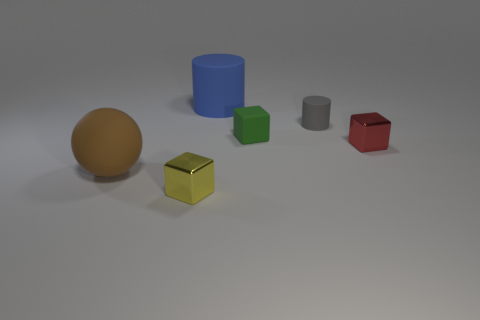Does the large rubber cylinder have the same color as the tiny rubber cylinder?
Make the answer very short. No. There is a object in front of the large object that is in front of the gray matte cylinder; what is its shape?
Provide a short and direct response. Cube. What shape is the gray thing that is made of the same material as the big cylinder?
Your response must be concise. Cylinder. How many other things are the same shape as the yellow metallic thing?
Your response must be concise. 2. There is a cube left of the blue rubber thing; is it the same size as the gray matte thing?
Your response must be concise. Yes. Is the number of green rubber objects that are behind the gray matte thing greater than the number of red things?
Your response must be concise. No. How many matte cubes are to the left of the tiny cube that is right of the gray matte cylinder?
Keep it short and to the point. 1. Are there fewer yellow cubes that are to the left of the tiny green cube than small shiny blocks?
Provide a succinct answer. Yes. There is a metal block that is in front of the metal cube on the right side of the yellow metallic thing; is there a cube that is on the right side of it?
Your response must be concise. Yes. Does the yellow object have the same material as the cylinder that is right of the small green matte block?
Give a very brief answer. No. 